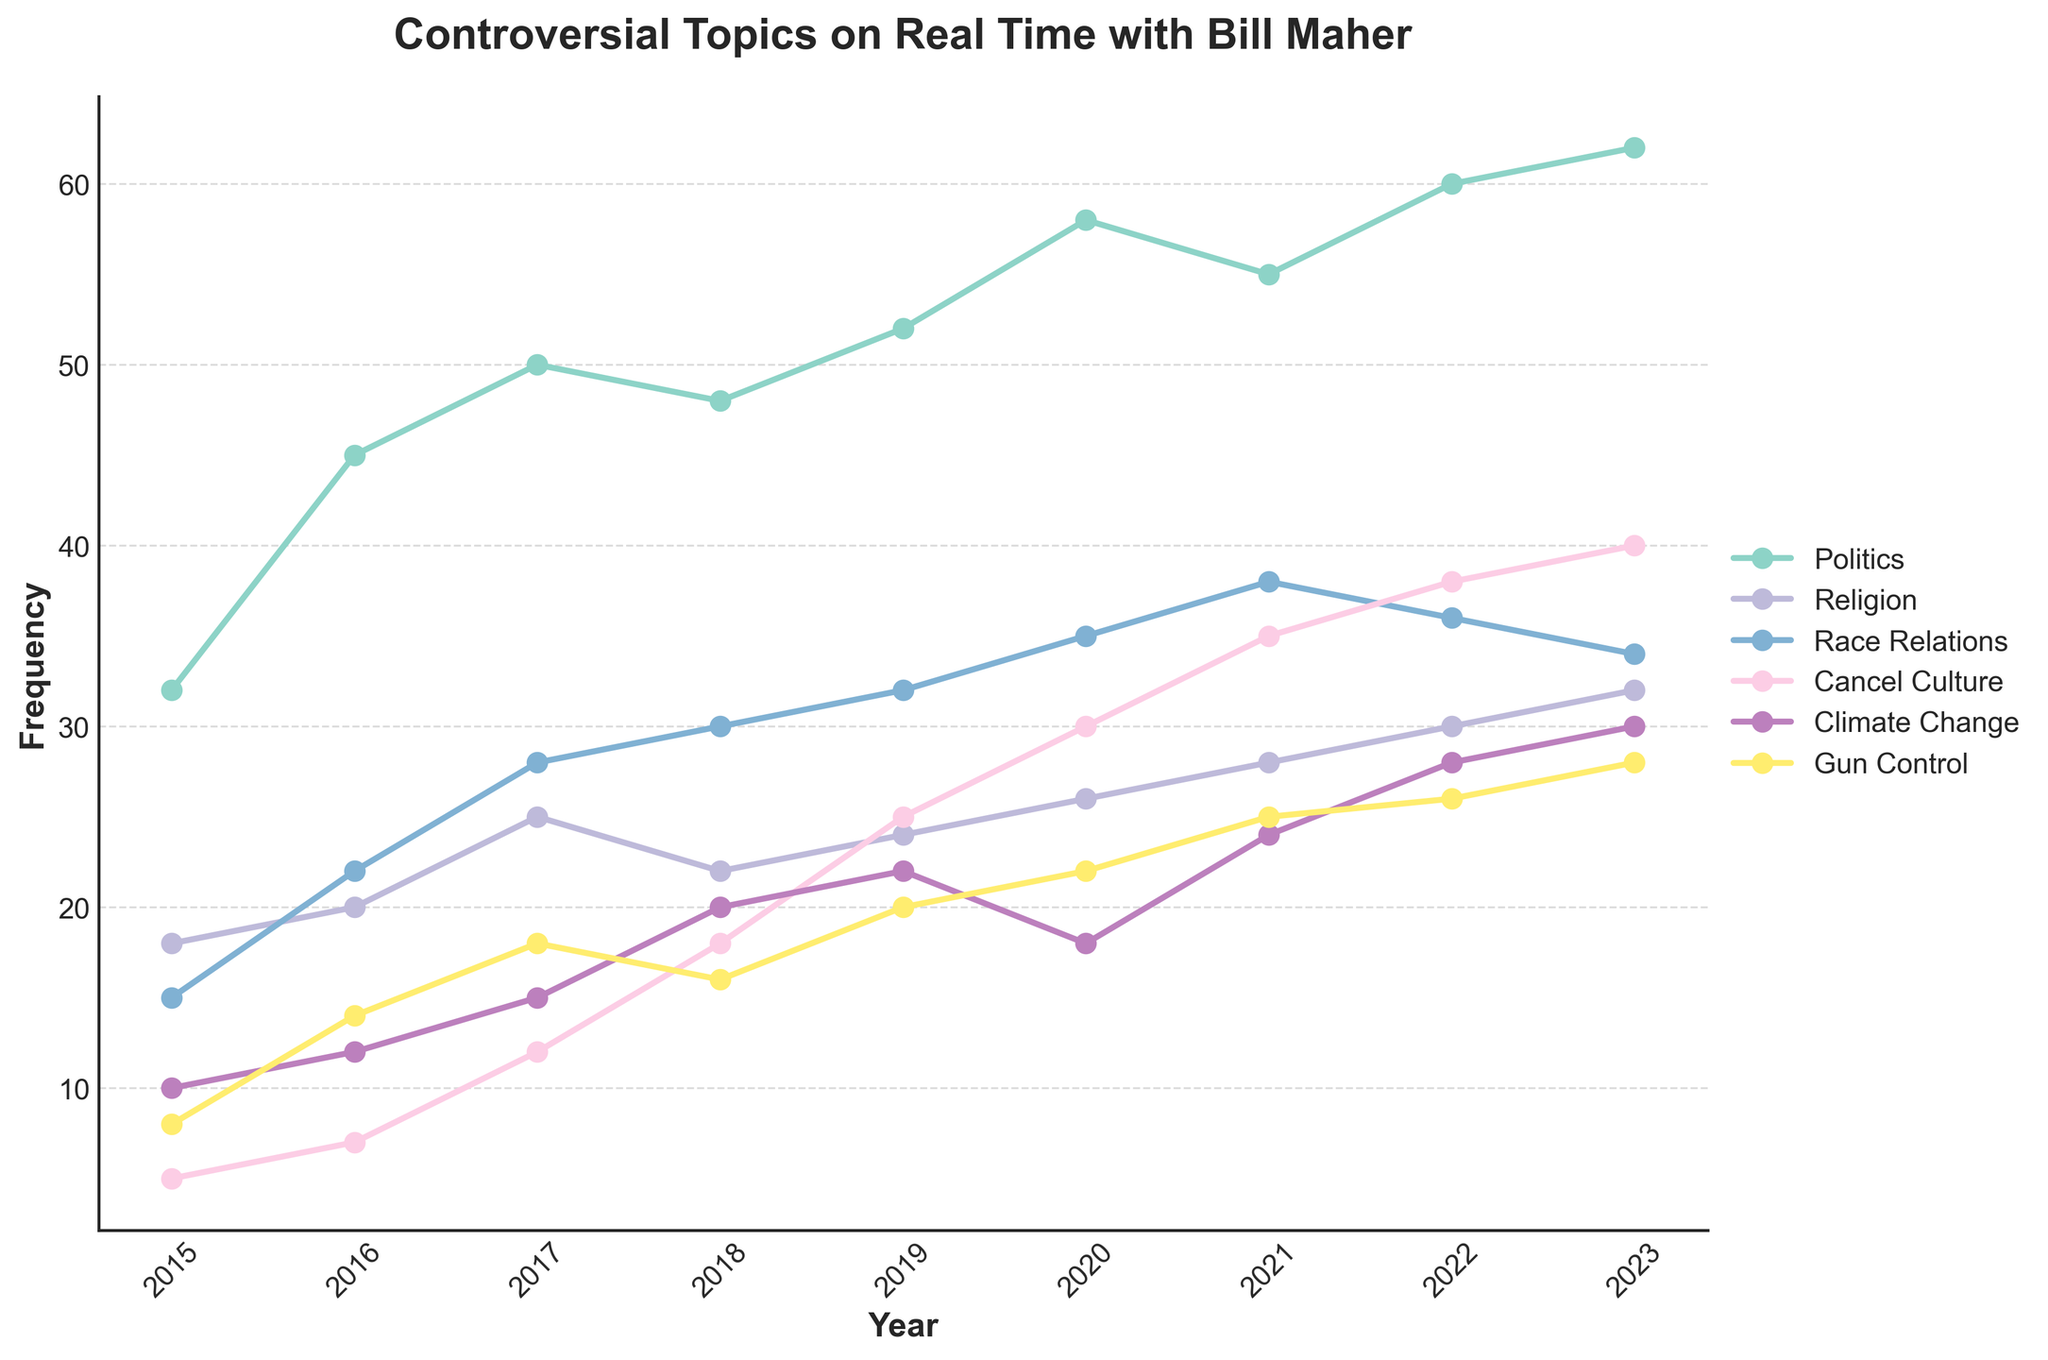What's the trend in the frequency of discussing politics from 2015 to 2023? To determine the trend in the frequency of politics discussion, observe the line representing Politics in the chart. The line starts at 32 in 2015 and ends at 62 in 2023, with a general upward trend every year.
Answer: Increasing Which year saw the biggest jump in the frequency of discussing cancel culture compared to the previous year? Look at the points on the Cancel Culture line. Identify the year-to-year differences: +2 (2015-2016), +5 (2016-2017), +6 (2017-2018), +7 (2018-2019), +5 (2019-2020), +5 (2020-2021), +3 (2021-2022), +2 (2022-2023). The biggest jump is 7 between 2018 and 2019.
Answer: 2019 Between 2015 and 2020, which controversial topic had the steepest increase in frequency? Compare the increase for all topics from 2015 to 2020. Politics increased by 26, Religion by 8, Race Relations by 20, Cancel Culture by 25, Climate Change by 8, Gun Control by 14. Cancel Culture has the steepest increase.
Answer: Cancel Culture In 2023, how does the frequency of discussing gun control compare to the frequency of discussing climate change? Locate the points for Gun Control and Climate Change in 2023. Gun Control is 28 and Climate Change is 30; compare these values directly.
Answer: 2 less What is the average frequency of discussing race relations between 2017 and 2021? Sum the frequencies for Race Relations from 2017 to 2021 (28 + 30 + 32 + 35 + 38 = 163). Divide the total by 5 years. 163/5 = 32.6
Answer: 32.6 Which topic showed the least increase in the entire period from 2015 to 2023? Calculate the overall increase for each topic. Politics: +30, Religion: +14, Race Relations: +19, Cancel Culture: +35, Climate Change: +20, Gun Control: +20. The Religion topic had the smallest increase.
Answer: Religion By how much did the frequency of discussing climate change increase from 2015 to 2023? Find the climate change frequencies for both years, and subtract the 2015 frequency from the 2023 frequency. 30 (2023) – 10 (2015) = 20
Answer: 20 Which year had an equal frequency of discussing politics and gun control? Scan through the chart to see where the frequency of Politics intersects with Gun Control. This only happens in 2016 where both frequencies are 45 and 14 respectively.
Answer: None Which topic had the highest frequency in 2022 and what was its value? Locate all the points for 2022. Determine the highest point, which is for Politics at 60.
Answer: Politics, 60 